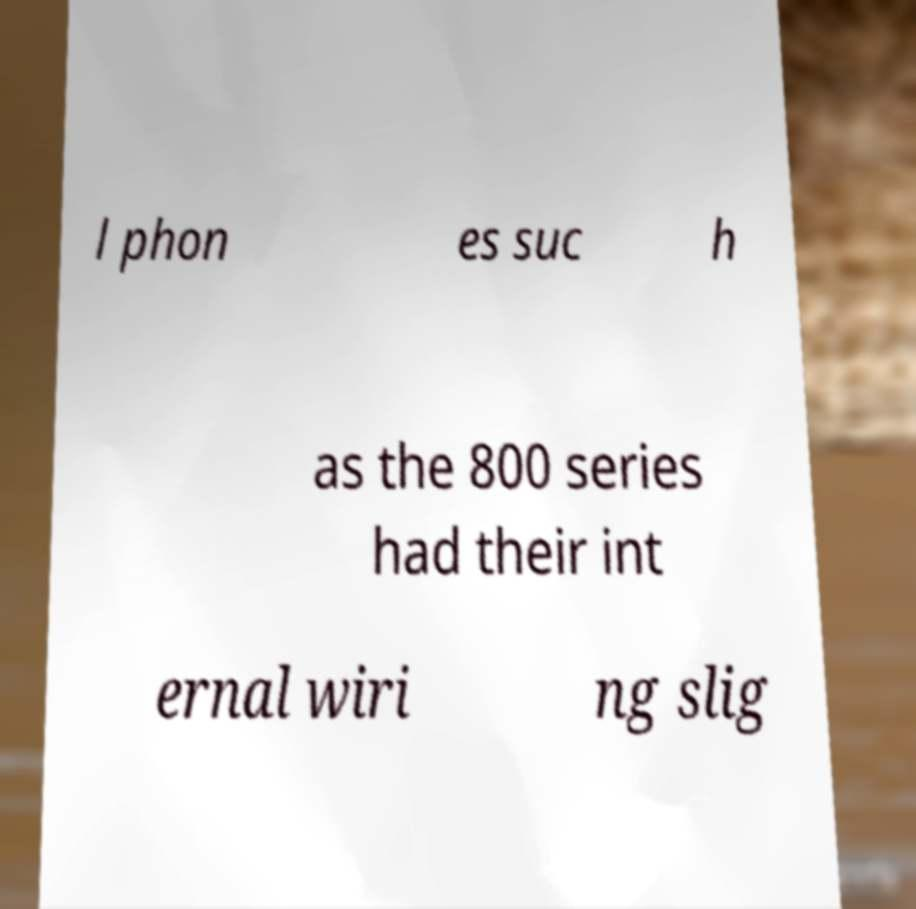For documentation purposes, I need the text within this image transcribed. Could you provide that? l phon es suc h as the 800 series had their int ernal wiri ng slig 